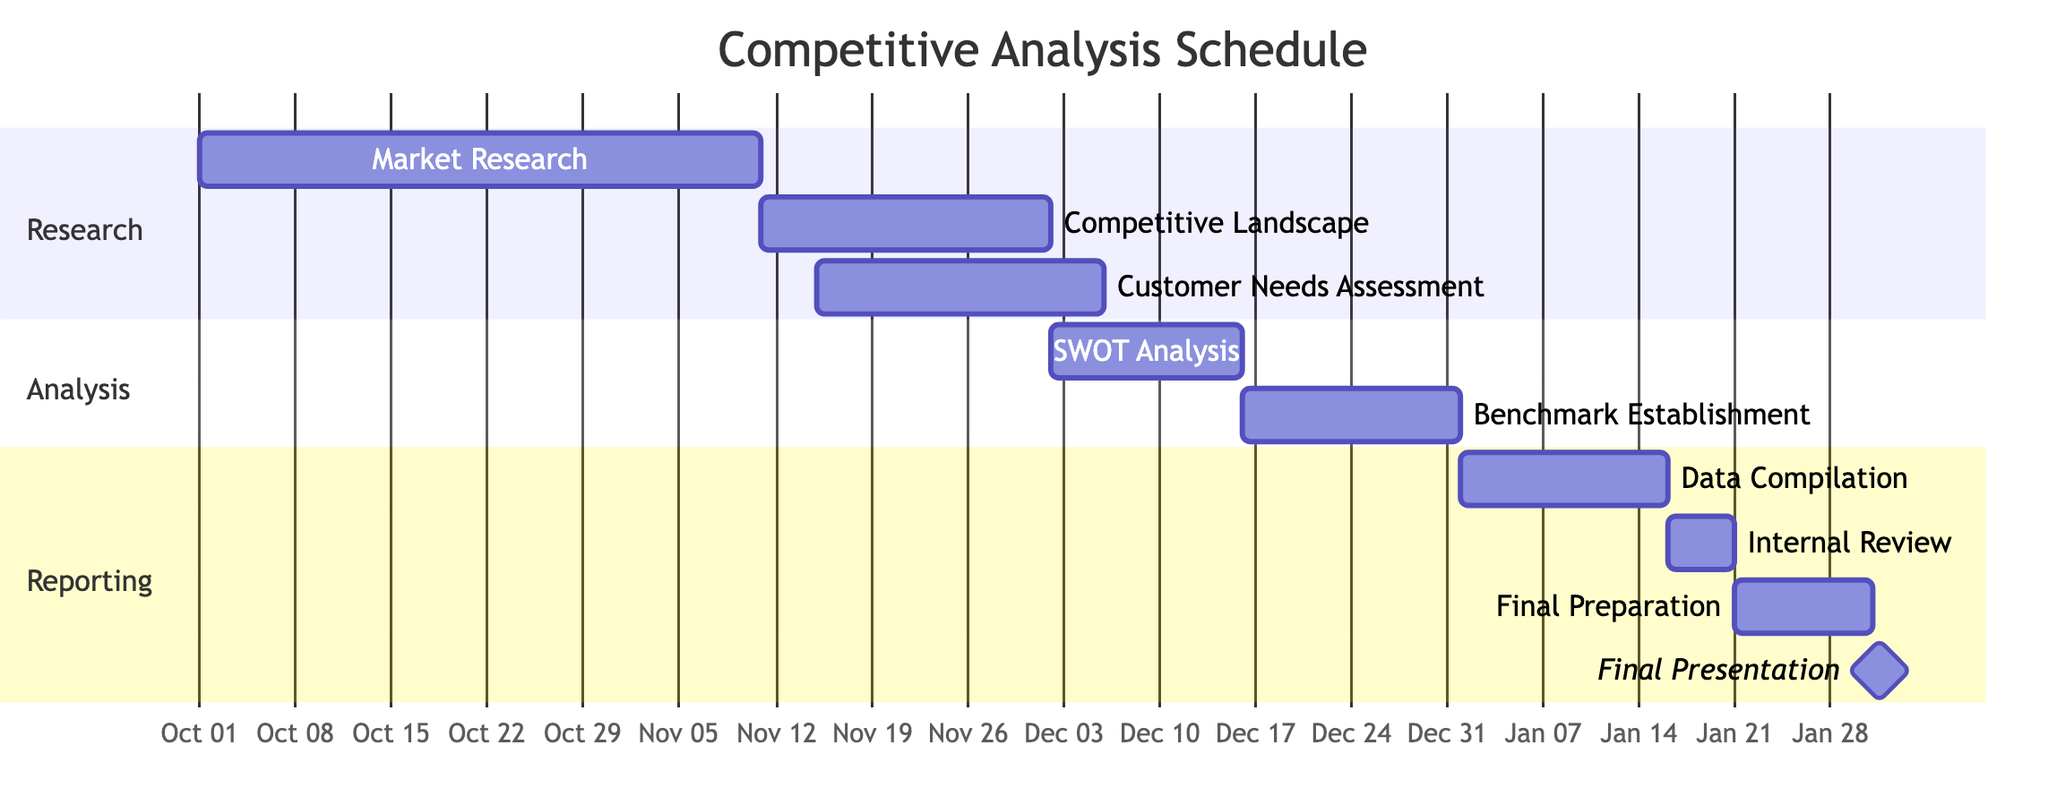What is the duration of the "Market Research" task? The "Market Research" task starts on October 1, 2023, and ends on November 10, 2023. The duration is calculated by finding the difference between the start and end dates, which gives a total of 41 days.
Answer: 41 days Which task follows the "Competitive Landscape Analysis"? The task that immediately follows "Competitive Landscape Analysis," which ends on December 1, 2023, is "Customer Needs Assessment," which starts on November 15, 2023. This indicates that there is an overlap in timing for these two tasks.
Answer: Customer Needs Assessment How many days are allocated for "Benchmark Establishment"? The "Benchmark Establishment" task starts on December 16, 2023, and ends on December 31, 2023. By calculating the difference between the two dates, it shows a duration of 16 days.
Answer: 16 days What are the tasks included in the "Reporting" section? The "Reporting" section includes three tasks: "Data Compilation," "Internal Review," and "Final Preparation." Each of these tasks is listed within this specific section of the Gantt chart.
Answer: Data Compilation, Internal Review, Final Preparation When does the "Final Presentation" occur? The "Final Presentation" is indicated as a milestone that occurs on January 31, 2024. It is the culmination of all previous tasks and signifies the completion of the competitive analysis project.
Answer: January 31, 2024 Which analysis task has the longest duration? Comparing the durations of all analysis tasks, "SWOT Analysis," which lasts from December 2, 2023, to December 15, 2023, spans 14 days. While "Benchmark Establishment" lasts for 16 days, which was identified in an earlier question, thus the former task, "SWOT Analysis," has the shorter duration. Though, it's important to analyze all tasks properly.
Answer: Benchmark Establishment At what point does the "Data Compilation and Report Preparation" start? The "Data Compilation and Report Preparation" task starts on January 1, 2024, as per the timeline provided in the Gantt chart. This marks the beginning of the reporting phase after the analysis tasks.
Answer: January 1, 2024 How many total tasks are represented in the Gantt chart? There are a total of nine tasks represented in the Gantt chart: three in the "Research" section, two in the "Analysis" section, and four in the "Reporting" section. By counting these tasks, one can derive the total.
Answer: Nine tasks 